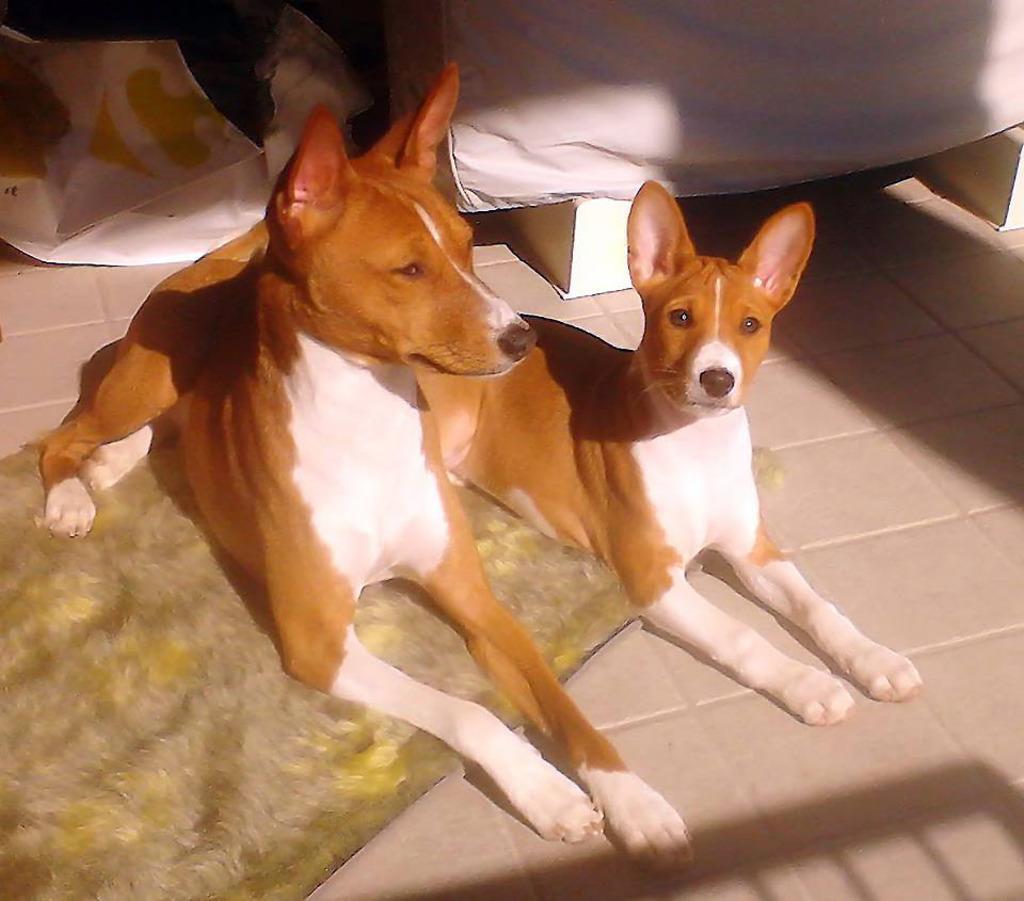In one or two sentences, can you explain what this image depicts? Here I can see two dogs. One is sitting on a mat and another one is sitting on the floor. In the background, I can see a white color cloth. 